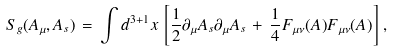Convert formula to latex. <formula><loc_0><loc_0><loc_500><loc_500>S _ { g } ( A _ { \mu } , A _ { s } ) \, = \, \int d ^ { 3 + 1 } x \, \left [ \frac { 1 } { 2 } \partial _ { \mu } A _ { s } \partial _ { \mu } A _ { s } \, + \, \frac { 1 } { 4 } F _ { \mu \nu } ( A ) F _ { \mu \nu } ( A ) \right ] \, ,</formula> 